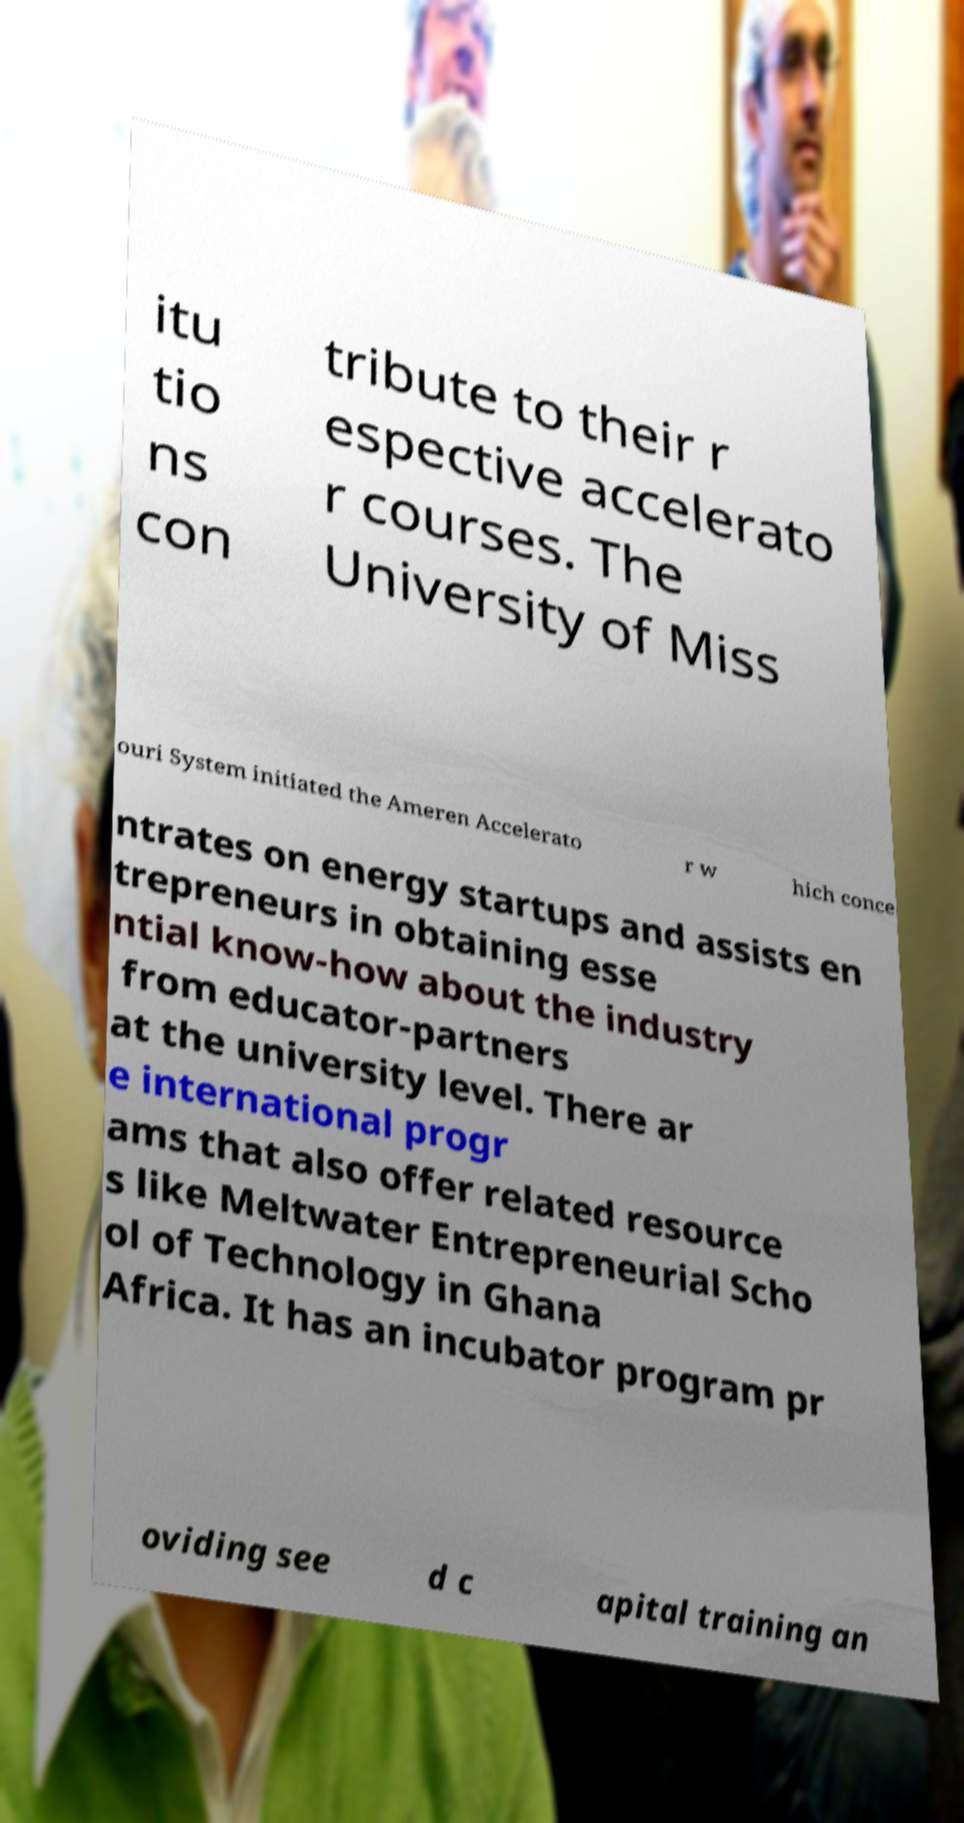I need the written content from this picture converted into text. Can you do that? itu tio ns con tribute to their r espective accelerato r courses. The University of Miss ouri System initiated the Ameren Accelerato r w hich conce ntrates on energy startups and assists en trepreneurs in obtaining esse ntial know-how about the industry from educator-partners at the university level. There ar e international progr ams that also offer related resource s like Meltwater Entrepreneurial Scho ol of Technology in Ghana Africa. It has an incubator program pr oviding see d c apital training an 